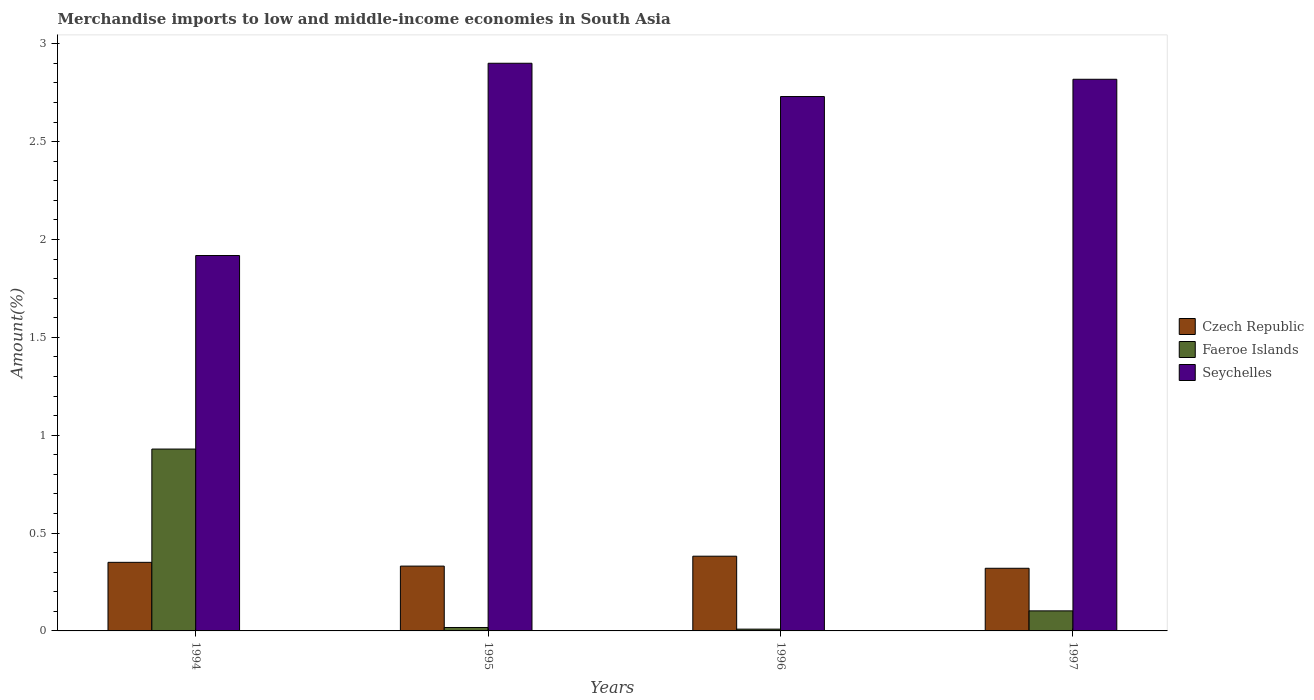How many groups of bars are there?
Your answer should be very brief. 4. Are the number of bars per tick equal to the number of legend labels?
Your response must be concise. Yes. Are the number of bars on each tick of the X-axis equal?
Provide a short and direct response. Yes. How many bars are there on the 2nd tick from the left?
Your response must be concise. 3. How many bars are there on the 3rd tick from the right?
Offer a very short reply. 3. In how many cases, is the number of bars for a given year not equal to the number of legend labels?
Make the answer very short. 0. What is the percentage of amount earned from merchandise imports in Seychelles in 1994?
Ensure brevity in your answer.  1.92. Across all years, what is the maximum percentage of amount earned from merchandise imports in Faeroe Islands?
Provide a succinct answer. 0.93. Across all years, what is the minimum percentage of amount earned from merchandise imports in Seychelles?
Keep it short and to the point. 1.92. In which year was the percentage of amount earned from merchandise imports in Seychelles maximum?
Make the answer very short. 1995. In which year was the percentage of amount earned from merchandise imports in Seychelles minimum?
Provide a succinct answer. 1994. What is the total percentage of amount earned from merchandise imports in Czech Republic in the graph?
Your answer should be very brief. 1.38. What is the difference between the percentage of amount earned from merchandise imports in Faeroe Islands in 1996 and that in 1997?
Offer a very short reply. -0.09. What is the difference between the percentage of amount earned from merchandise imports in Seychelles in 1996 and the percentage of amount earned from merchandise imports in Czech Republic in 1994?
Provide a short and direct response. 2.38. What is the average percentage of amount earned from merchandise imports in Seychelles per year?
Make the answer very short. 2.59. In the year 1995, what is the difference between the percentage of amount earned from merchandise imports in Seychelles and percentage of amount earned from merchandise imports in Czech Republic?
Your response must be concise. 2.57. What is the ratio of the percentage of amount earned from merchandise imports in Czech Republic in 1995 to that in 1996?
Keep it short and to the point. 0.87. Is the percentage of amount earned from merchandise imports in Faeroe Islands in 1994 less than that in 1996?
Your response must be concise. No. Is the difference between the percentage of amount earned from merchandise imports in Seychelles in 1995 and 1997 greater than the difference between the percentage of amount earned from merchandise imports in Czech Republic in 1995 and 1997?
Provide a succinct answer. Yes. What is the difference between the highest and the second highest percentage of amount earned from merchandise imports in Seychelles?
Your answer should be very brief. 0.08. What is the difference between the highest and the lowest percentage of amount earned from merchandise imports in Faeroe Islands?
Keep it short and to the point. 0.92. In how many years, is the percentage of amount earned from merchandise imports in Czech Republic greater than the average percentage of amount earned from merchandise imports in Czech Republic taken over all years?
Provide a short and direct response. 2. What does the 1st bar from the left in 1996 represents?
Provide a short and direct response. Czech Republic. What does the 3rd bar from the right in 1994 represents?
Make the answer very short. Czech Republic. How many bars are there?
Give a very brief answer. 12. Are all the bars in the graph horizontal?
Provide a short and direct response. No. How many years are there in the graph?
Provide a short and direct response. 4. Does the graph contain any zero values?
Your answer should be very brief. No. How are the legend labels stacked?
Offer a terse response. Vertical. What is the title of the graph?
Ensure brevity in your answer.  Merchandise imports to low and middle-income economies in South Asia. What is the label or title of the X-axis?
Keep it short and to the point. Years. What is the label or title of the Y-axis?
Offer a very short reply. Amount(%). What is the Amount(%) of Czech Republic in 1994?
Ensure brevity in your answer.  0.35. What is the Amount(%) of Faeroe Islands in 1994?
Your answer should be very brief. 0.93. What is the Amount(%) of Seychelles in 1994?
Give a very brief answer. 1.92. What is the Amount(%) of Czech Republic in 1995?
Make the answer very short. 0.33. What is the Amount(%) in Faeroe Islands in 1995?
Keep it short and to the point. 0.02. What is the Amount(%) of Seychelles in 1995?
Make the answer very short. 2.9. What is the Amount(%) in Czech Republic in 1996?
Keep it short and to the point. 0.38. What is the Amount(%) of Faeroe Islands in 1996?
Your answer should be very brief. 0.01. What is the Amount(%) of Seychelles in 1996?
Provide a short and direct response. 2.73. What is the Amount(%) of Czech Republic in 1997?
Provide a short and direct response. 0.32. What is the Amount(%) of Faeroe Islands in 1997?
Keep it short and to the point. 0.1. What is the Amount(%) of Seychelles in 1997?
Keep it short and to the point. 2.82. Across all years, what is the maximum Amount(%) in Czech Republic?
Give a very brief answer. 0.38. Across all years, what is the maximum Amount(%) of Faeroe Islands?
Keep it short and to the point. 0.93. Across all years, what is the maximum Amount(%) of Seychelles?
Offer a terse response. 2.9. Across all years, what is the minimum Amount(%) in Czech Republic?
Provide a short and direct response. 0.32. Across all years, what is the minimum Amount(%) in Faeroe Islands?
Keep it short and to the point. 0.01. Across all years, what is the minimum Amount(%) in Seychelles?
Offer a terse response. 1.92. What is the total Amount(%) of Czech Republic in the graph?
Keep it short and to the point. 1.38. What is the total Amount(%) in Faeroe Islands in the graph?
Offer a very short reply. 1.06. What is the total Amount(%) in Seychelles in the graph?
Your answer should be compact. 10.37. What is the difference between the Amount(%) of Czech Republic in 1994 and that in 1995?
Your response must be concise. 0.02. What is the difference between the Amount(%) in Faeroe Islands in 1994 and that in 1995?
Your response must be concise. 0.91. What is the difference between the Amount(%) in Seychelles in 1994 and that in 1995?
Your answer should be very brief. -0.98. What is the difference between the Amount(%) of Czech Republic in 1994 and that in 1996?
Give a very brief answer. -0.03. What is the difference between the Amount(%) in Faeroe Islands in 1994 and that in 1996?
Provide a succinct answer. 0.92. What is the difference between the Amount(%) in Seychelles in 1994 and that in 1996?
Make the answer very short. -0.81. What is the difference between the Amount(%) in Czech Republic in 1994 and that in 1997?
Offer a very short reply. 0.03. What is the difference between the Amount(%) of Faeroe Islands in 1994 and that in 1997?
Offer a terse response. 0.83. What is the difference between the Amount(%) in Seychelles in 1994 and that in 1997?
Provide a short and direct response. -0.9. What is the difference between the Amount(%) of Czech Republic in 1995 and that in 1996?
Offer a terse response. -0.05. What is the difference between the Amount(%) in Faeroe Islands in 1995 and that in 1996?
Your answer should be very brief. 0.01. What is the difference between the Amount(%) of Seychelles in 1995 and that in 1996?
Your answer should be very brief. 0.17. What is the difference between the Amount(%) in Czech Republic in 1995 and that in 1997?
Provide a short and direct response. 0.01. What is the difference between the Amount(%) of Faeroe Islands in 1995 and that in 1997?
Offer a terse response. -0.09. What is the difference between the Amount(%) in Seychelles in 1995 and that in 1997?
Make the answer very short. 0.08. What is the difference between the Amount(%) of Czech Republic in 1996 and that in 1997?
Provide a succinct answer. 0.06. What is the difference between the Amount(%) in Faeroe Islands in 1996 and that in 1997?
Offer a very short reply. -0.09. What is the difference between the Amount(%) in Seychelles in 1996 and that in 1997?
Your answer should be very brief. -0.09. What is the difference between the Amount(%) of Czech Republic in 1994 and the Amount(%) of Faeroe Islands in 1995?
Provide a succinct answer. 0.33. What is the difference between the Amount(%) in Czech Republic in 1994 and the Amount(%) in Seychelles in 1995?
Your response must be concise. -2.55. What is the difference between the Amount(%) of Faeroe Islands in 1994 and the Amount(%) of Seychelles in 1995?
Provide a short and direct response. -1.97. What is the difference between the Amount(%) of Czech Republic in 1994 and the Amount(%) of Faeroe Islands in 1996?
Give a very brief answer. 0.34. What is the difference between the Amount(%) in Czech Republic in 1994 and the Amount(%) in Seychelles in 1996?
Make the answer very short. -2.38. What is the difference between the Amount(%) of Faeroe Islands in 1994 and the Amount(%) of Seychelles in 1996?
Provide a succinct answer. -1.8. What is the difference between the Amount(%) in Czech Republic in 1994 and the Amount(%) in Faeroe Islands in 1997?
Keep it short and to the point. 0.25. What is the difference between the Amount(%) in Czech Republic in 1994 and the Amount(%) in Seychelles in 1997?
Your response must be concise. -2.47. What is the difference between the Amount(%) in Faeroe Islands in 1994 and the Amount(%) in Seychelles in 1997?
Ensure brevity in your answer.  -1.89. What is the difference between the Amount(%) in Czech Republic in 1995 and the Amount(%) in Faeroe Islands in 1996?
Give a very brief answer. 0.32. What is the difference between the Amount(%) in Czech Republic in 1995 and the Amount(%) in Seychelles in 1996?
Give a very brief answer. -2.4. What is the difference between the Amount(%) of Faeroe Islands in 1995 and the Amount(%) of Seychelles in 1996?
Provide a short and direct response. -2.71. What is the difference between the Amount(%) in Czech Republic in 1995 and the Amount(%) in Faeroe Islands in 1997?
Provide a short and direct response. 0.23. What is the difference between the Amount(%) of Czech Republic in 1995 and the Amount(%) of Seychelles in 1997?
Keep it short and to the point. -2.49. What is the difference between the Amount(%) of Faeroe Islands in 1995 and the Amount(%) of Seychelles in 1997?
Your answer should be compact. -2.8. What is the difference between the Amount(%) in Czech Republic in 1996 and the Amount(%) in Faeroe Islands in 1997?
Give a very brief answer. 0.28. What is the difference between the Amount(%) in Czech Republic in 1996 and the Amount(%) in Seychelles in 1997?
Your response must be concise. -2.44. What is the difference between the Amount(%) in Faeroe Islands in 1996 and the Amount(%) in Seychelles in 1997?
Offer a terse response. -2.81. What is the average Amount(%) in Czech Republic per year?
Keep it short and to the point. 0.35. What is the average Amount(%) in Faeroe Islands per year?
Offer a very short reply. 0.26. What is the average Amount(%) in Seychelles per year?
Provide a succinct answer. 2.59. In the year 1994, what is the difference between the Amount(%) in Czech Republic and Amount(%) in Faeroe Islands?
Offer a very short reply. -0.58. In the year 1994, what is the difference between the Amount(%) in Czech Republic and Amount(%) in Seychelles?
Provide a short and direct response. -1.57. In the year 1994, what is the difference between the Amount(%) in Faeroe Islands and Amount(%) in Seychelles?
Your answer should be very brief. -0.99. In the year 1995, what is the difference between the Amount(%) of Czech Republic and Amount(%) of Faeroe Islands?
Offer a very short reply. 0.31. In the year 1995, what is the difference between the Amount(%) in Czech Republic and Amount(%) in Seychelles?
Ensure brevity in your answer.  -2.57. In the year 1995, what is the difference between the Amount(%) of Faeroe Islands and Amount(%) of Seychelles?
Provide a short and direct response. -2.88. In the year 1996, what is the difference between the Amount(%) of Czech Republic and Amount(%) of Faeroe Islands?
Offer a terse response. 0.37. In the year 1996, what is the difference between the Amount(%) of Czech Republic and Amount(%) of Seychelles?
Your answer should be very brief. -2.35. In the year 1996, what is the difference between the Amount(%) in Faeroe Islands and Amount(%) in Seychelles?
Your answer should be very brief. -2.72. In the year 1997, what is the difference between the Amount(%) of Czech Republic and Amount(%) of Faeroe Islands?
Ensure brevity in your answer.  0.22. In the year 1997, what is the difference between the Amount(%) of Czech Republic and Amount(%) of Seychelles?
Your response must be concise. -2.5. In the year 1997, what is the difference between the Amount(%) in Faeroe Islands and Amount(%) in Seychelles?
Provide a short and direct response. -2.72. What is the ratio of the Amount(%) in Czech Republic in 1994 to that in 1995?
Your answer should be very brief. 1.06. What is the ratio of the Amount(%) of Faeroe Islands in 1994 to that in 1995?
Your answer should be very brief. 53.09. What is the ratio of the Amount(%) of Seychelles in 1994 to that in 1995?
Your response must be concise. 0.66. What is the ratio of the Amount(%) in Czech Republic in 1994 to that in 1996?
Make the answer very short. 0.92. What is the ratio of the Amount(%) of Faeroe Islands in 1994 to that in 1996?
Your answer should be very brief. 101.53. What is the ratio of the Amount(%) of Seychelles in 1994 to that in 1996?
Keep it short and to the point. 0.7. What is the ratio of the Amount(%) in Czech Republic in 1994 to that in 1997?
Your response must be concise. 1.09. What is the ratio of the Amount(%) in Faeroe Islands in 1994 to that in 1997?
Offer a terse response. 9.07. What is the ratio of the Amount(%) in Seychelles in 1994 to that in 1997?
Your answer should be compact. 0.68. What is the ratio of the Amount(%) of Czech Republic in 1995 to that in 1996?
Offer a very short reply. 0.87. What is the ratio of the Amount(%) of Faeroe Islands in 1995 to that in 1996?
Your answer should be compact. 1.91. What is the ratio of the Amount(%) in Seychelles in 1995 to that in 1996?
Provide a short and direct response. 1.06. What is the ratio of the Amount(%) of Czech Republic in 1995 to that in 1997?
Provide a succinct answer. 1.03. What is the ratio of the Amount(%) of Faeroe Islands in 1995 to that in 1997?
Provide a succinct answer. 0.17. What is the ratio of the Amount(%) of Czech Republic in 1996 to that in 1997?
Your response must be concise. 1.19. What is the ratio of the Amount(%) in Faeroe Islands in 1996 to that in 1997?
Provide a succinct answer. 0.09. What is the ratio of the Amount(%) of Seychelles in 1996 to that in 1997?
Provide a succinct answer. 0.97. What is the difference between the highest and the second highest Amount(%) of Czech Republic?
Make the answer very short. 0.03. What is the difference between the highest and the second highest Amount(%) of Faeroe Islands?
Your response must be concise. 0.83. What is the difference between the highest and the second highest Amount(%) of Seychelles?
Your answer should be compact. 0.08. What is the difference between the highest and the lowest Amount(%) in Czech Republic?
Provide a succinct answer. 0.06. What is the difference between the highest and the lowest Amount(%) in Faeroe Islands?
Offer a very short reply. 0.92. What is the difference between the highest and the lowest Amount(%) in Seychelles?
Ensure brevity in your answer.  0.98. 